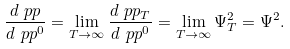<formula> <loc_0><loc_0><loc_500><loc_500>\frac { d \ p p } { d \ p p ^ { 0 } } = \lim _ { T \to \infty } \frac { d \ p p _ { T } } { d \ p p ^ { 0 } } = \lim _ { T \to \infty } \Psi ^ { 2 } _ { T } = \Psi ^ { 2 } .</formula> 